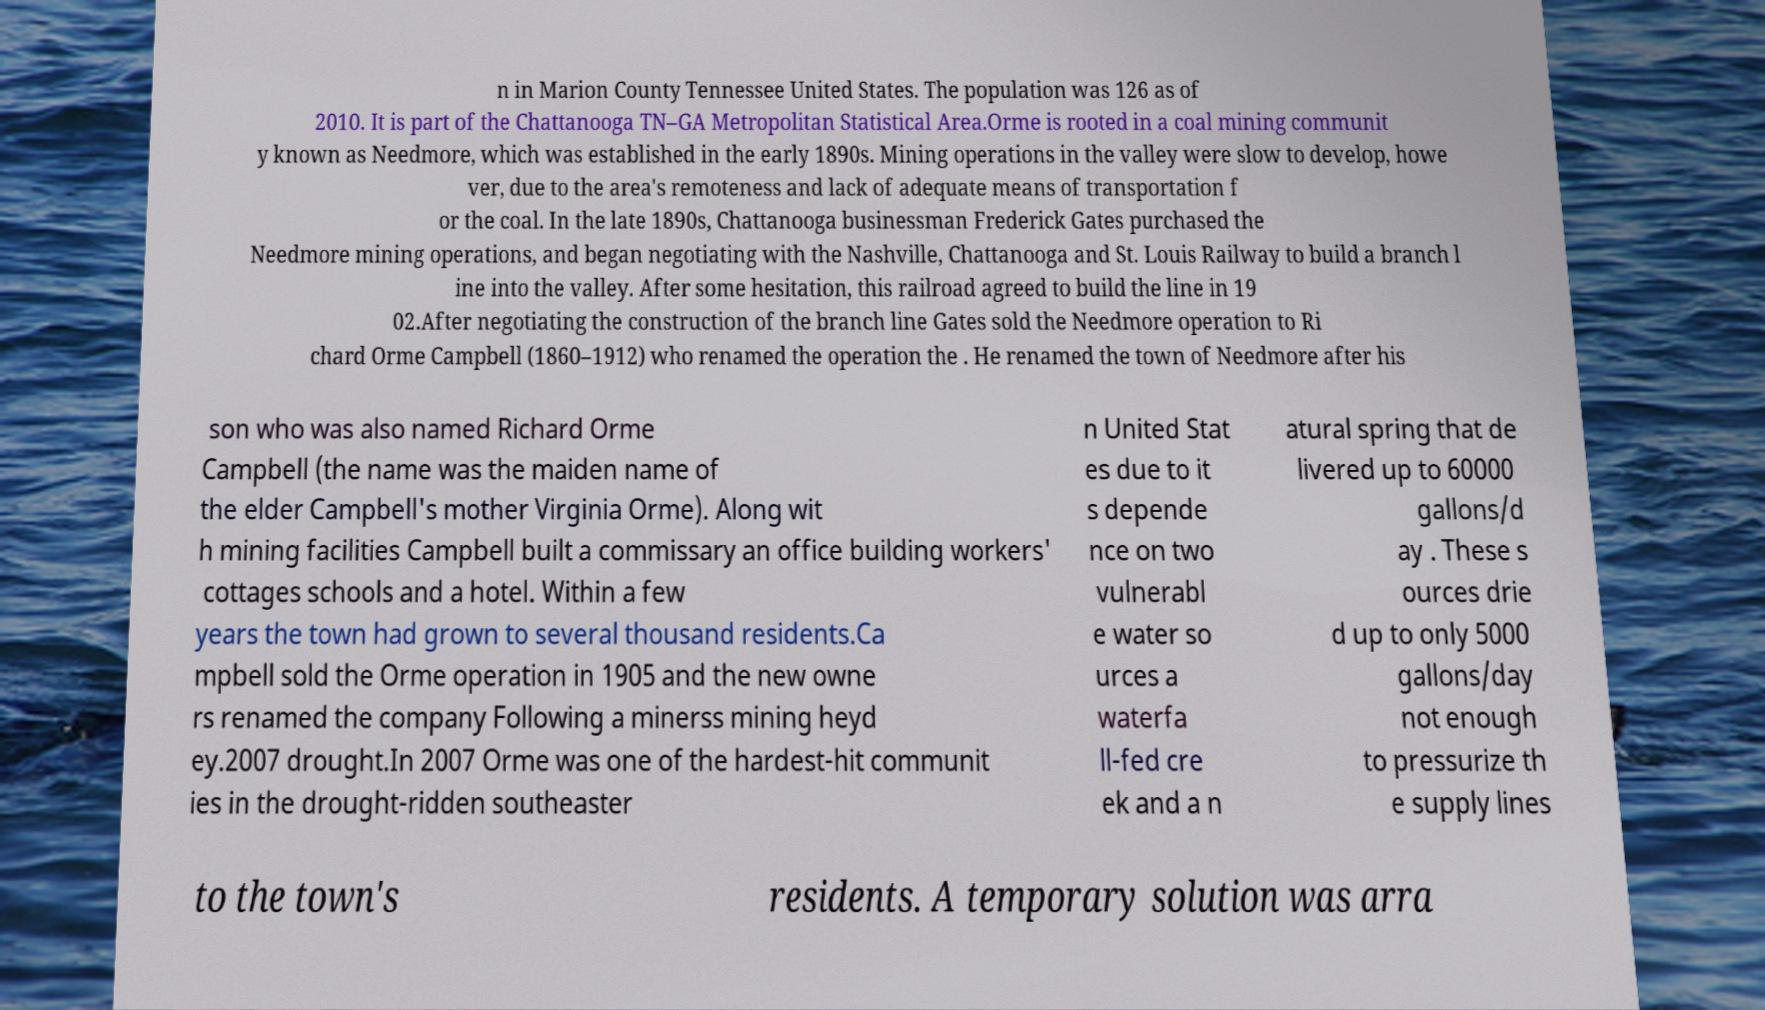What messages or text are displayed in this image? I need them in a readable, typed format. n in Marion County Tennessee United States. The population was 126 as of 2010. It is part of the Chattanooga TN–GA Metropolitan Statistical Area.Orme is rooted in a coal mining communit y known as Needmore, which was established in the early 1890s. Mining operations in the valley were slow to develop, howe ver, due to the area's remoteness and lack of adequate means of transportation f or the coal. In the late 1890s, Chattanooga businessman Frederick Gates purchased the Needmore mining operations, and began negotiating with the Nashville, Chattanooga and St. Louis Railway to build a branch l ine into the valley. After some hesitation, this railroad agreed to build the line in 19 02.After negotiating the construction of the branch line Gates sold the Needmore operation to Ri chard Orme Campbell (1860–1912) who renamed the operation the . He renamed the town of Needmore after his son who was also named Richard Orme Campbell (the name was the maiden name of the elder Campbell's mother Virginia Orme). Along wit h mining facilities Campbell built a commissary an office building workers' cottages schools and a hotel. Within a few years the town had grown to several thousand residents.Ca mpbell sold the Orme operation in 1905 and the new owne rs renamed the company Following a minerss mining heyd ey.2007 drought.In 2007 Orme was one of the hardest-hit communit ies in the drought-ridden southeaster n United Stat es due to it s depende nce on two vulnerabl e water so urces a waterfa ll-fed cre ek and a n atural spring that de livered up to 60000 gallons/d ay . These s ources drie d up to only 5000 gallons/day not enough to pressurize th e supply lines to the town's residents. A temporary solution was arra 